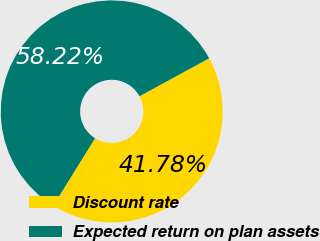Convert chart. <chart><loc_0><loc_0><loc_500><loc_500><pie_chart><fcel>Discount rate<fcel>Expected return on plan assets<nl><fcel>41.78%<fcel>58.22%<nl></chart> 